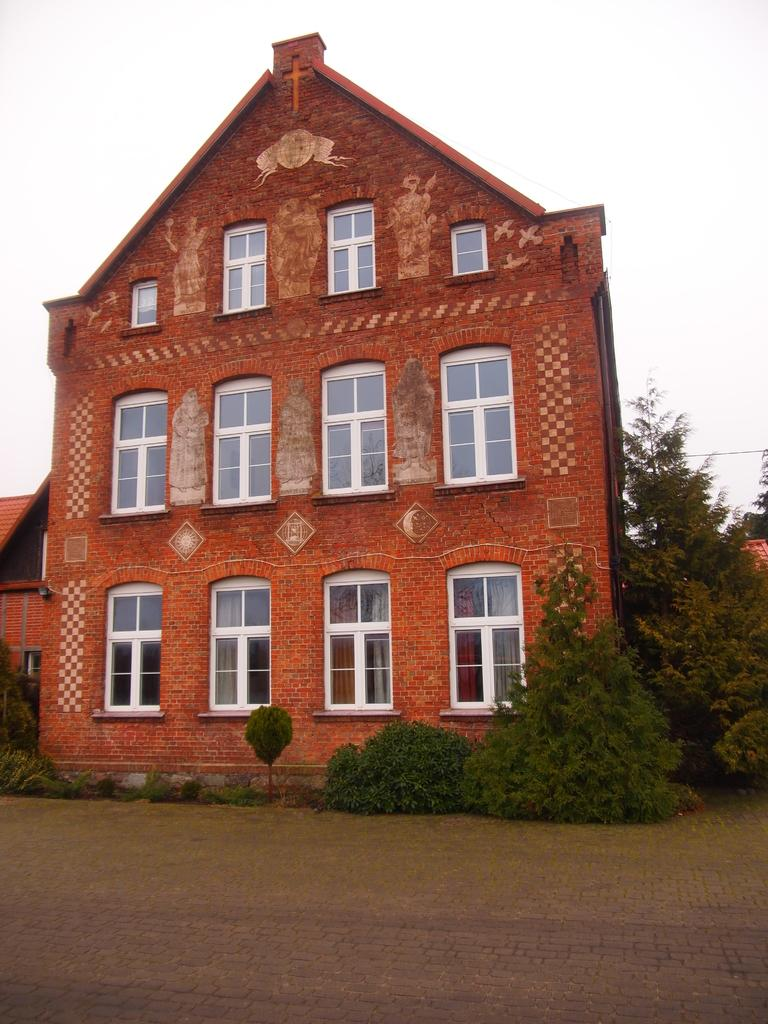What type of living organisms can be seen in the image? There are plants in the image. What color are the plants? The plants are green. What can be seen in the background of the image? There is a building in the background of the image. What is the color of the building? The building is brown. What feature can be observed on the building? There are glass windows on the building. What is the color of the sky in the image? The sky is white in color. What type of drug can be seen in the image? There is no drug present in the image; it features plants, a building, and a white sky. What type of frame is used to hold the plants in the image? There is no frame visible in the image; the plants are not contained within a frame. 